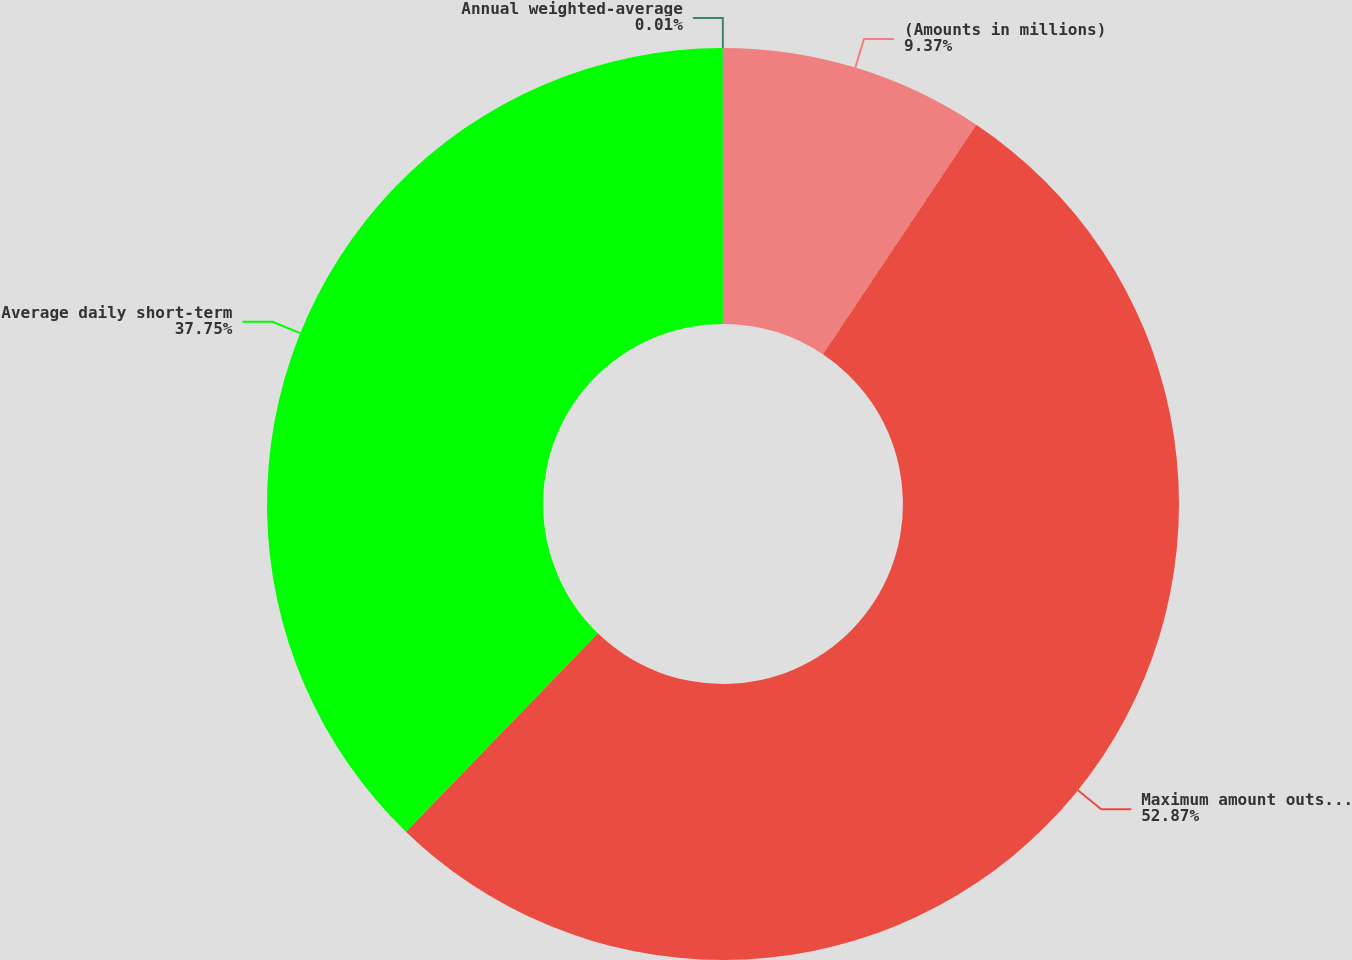Convert chart. <chart><loc_0><loc_0><loc_500><loc_500><pie_chart><fcel>(Amounts in millions)<fcel>Maximum amount outstanding at<fcel>Average daily short-term<fcel>Annual weighted-average<nl><fcel>9.37%<fcel>52.87%<fcel>37.75%<fcel>0.01%<nl></chart> 